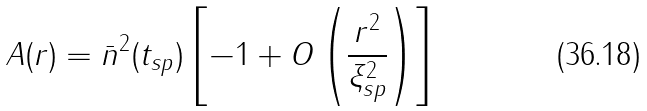Convert formula to latex. <formula><loc_0><loc_0><loc_500><loc_500>A ( r ) = { \bar { n } } ^ { 2 } ( t _ { s p } ) \left [ - 1 + O \left ( \frac { r ^ { 2 } } { \xi _ { s p } ^ { 2 } } \right ) \right ]</formula> 